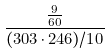<formula> <loc_0><loc_0><loc_500><loc_500>\frac { \frac { 9 } { 6 0 } } { ( 3 0 3 \cdot 2 4 6 ) / 1 0 }</formula> 